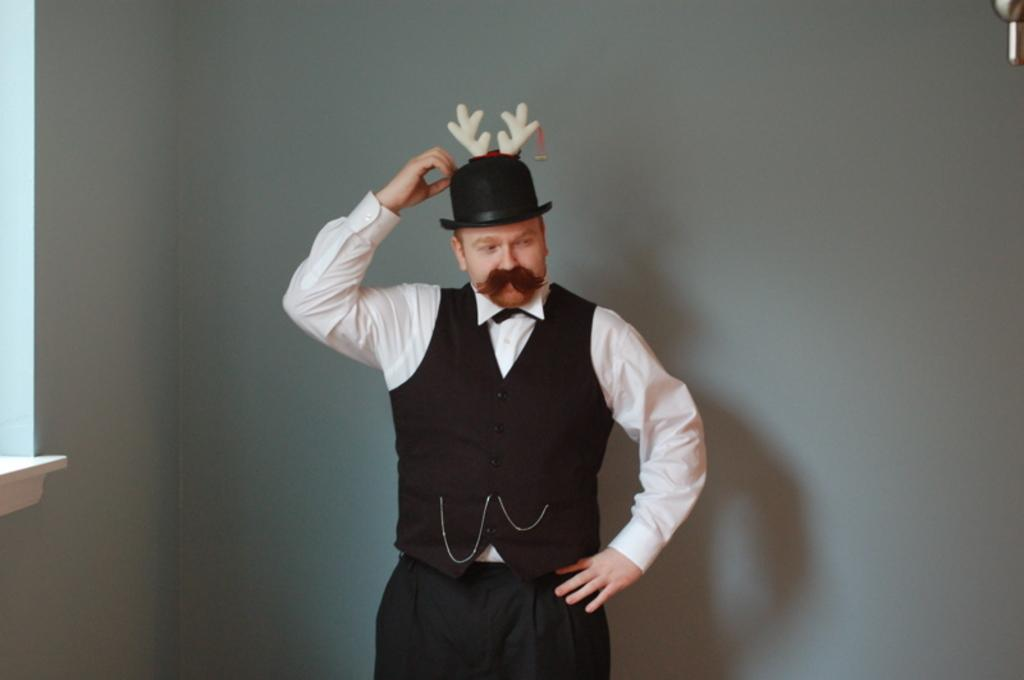Who is the main subject in the picture? There is a man in the middle of the picture. What is the man wearing on his upper body? The man is wearing a white shirt and a black coat. What type of headwear is the man wearing? The man is wearing a black hat. What can be seen in the background of the picture? There is a wall in the background of the picture. What color is the wall in the image? The wall is white in color. Can you see a pail being used by the man in the image? There is no pail visible in the image. Is the man walking along a river in the picture? There is no river present in the image; it only features a man and a wall in the background. 